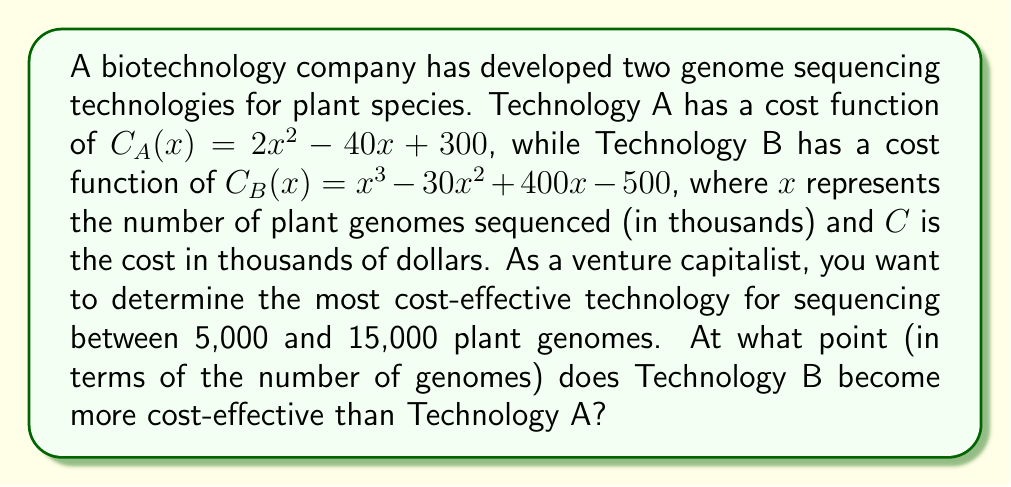Show me your answer to this math problem. To solve this problem, we need to find the intersection point of the two cost functions within the given range. This point represents where Technology B becomes more cost-effective than Technology A.

1. Set up the equation:
   $C_A(x) = C_B(x)$
   $2x^2 - 40x + 300 = x^3 - 30x^2 + 400x - 500$

2. Rearrange the equation:
   $x^3 - 32x^2 + 440x - 800 = 0$

3. This is a cubic equation. We can solve it using the rational root theorem or a graphing calculator. The solutions are approximately $x = 5.73$, $x = 16.94$, and $x = 9.33$.

4. Given the range of 5,000 to 15,000 genomes, we're interested in $x$ values between 5 and 15 (remember, $x$ is in thousands).

5. The only solution within this range is $x ≈ 9.33$.

6. To verify that Technology B becomes more cost-effective after this point, we can check the costs at $x = 9.5$:

   $C_A(9.5) = 2(9.5)^2 - 40(9.5) + 300 = 180.5$ thousand dollars
   $C_B(9.5) = (9.5)^3 - 30(9.5)^2 + 400(9.5) - 500 ≈ 179.875$ thousand dollars

   Indeed, $C_B(9.5) < C_A(9.5)$, confirming that Technology B is more cost-effective after the intersection point.
Answer: Technology B becomes more cost-effective than Technology A at approximately 9,330 plant genomes. 